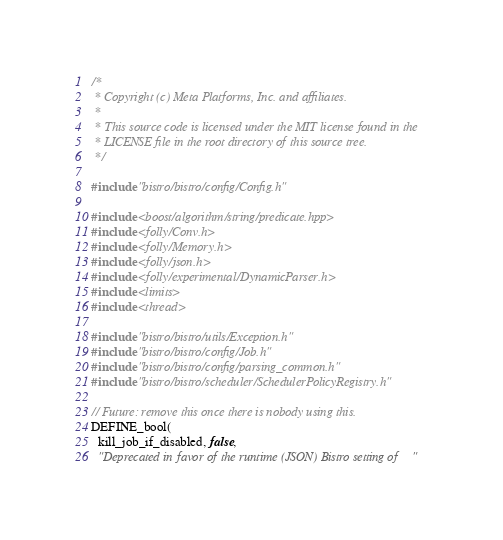<code> <loc_0><loc_0><loc_500><loc_500><_C++_>/*
 * Copyright (c) Meta Platforms, Inc. and affiliates.
 *
 * This source code is licensed under the MIT license found in the
 * LICENSE file in the root directory of this source tree.
 */

#include "bistro/bistro/config/Config.h"

#include <boost/algorithm/string/predicate.hpp>
#include <folly/Conv.h>
#include <folly/Memory.h>
#include <folly/json.h>
#include <folly/experimental/DynamicParser.h>
#include <limits>
#include <thread>

#include "bistro/bistro/utils/Exception.h"
#include "bistro/bistro/config/Job.h"
#include "bistro/bistro/config/parsing_common.h"
#include "bistro/bistro/scheduler/SchedulerPolicyRegistry.h"

// Future: remove this once there is nobody using this.
DEFINE_bool(
  kill_job_if_disabled, false,
  "Deprecated in favor of the runtime (JSON) Bistro setting of "</code> 